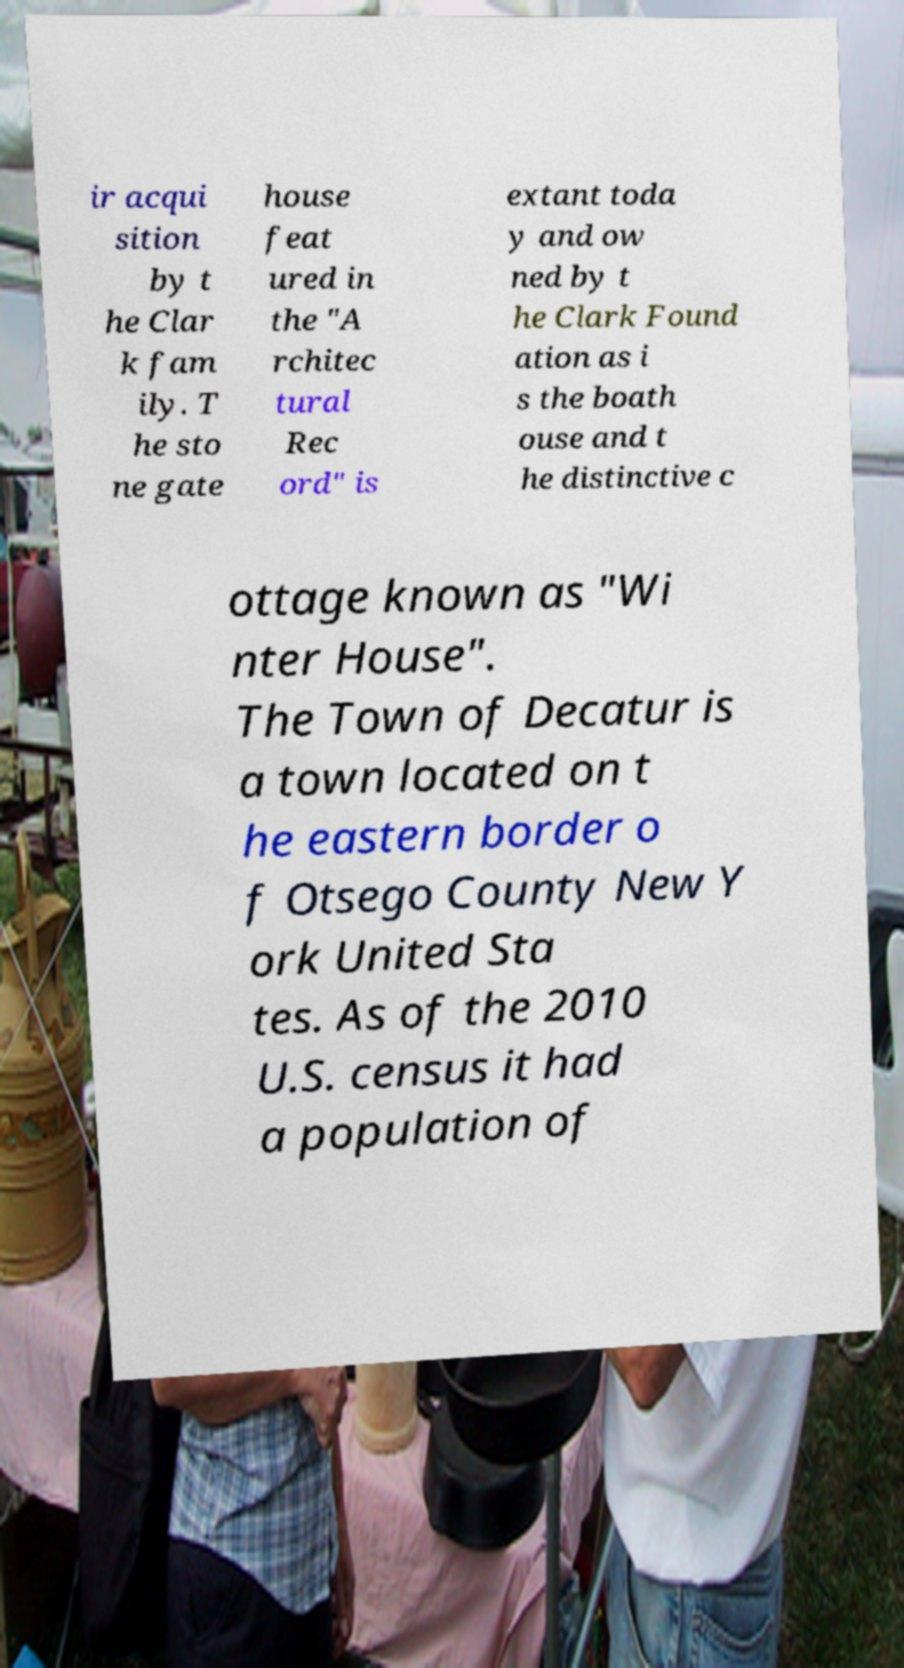Could you assist in decoding the text presented in this image and type it out clearly? ir acqui sition by t he Clar k fam ily. T he sto ne gate house feat ured in the "A rchitec tural Rec ord" is extant toda y and ow ned by t he Clark Found ation as i s the boath ouse and t he distinctive c ottage known as "Wi nter House". The Town of Decatur is a town located on t he eastern border o f Otsego County New Y ork United Sta tes. As of the 2010 U.S. census it had a population of 